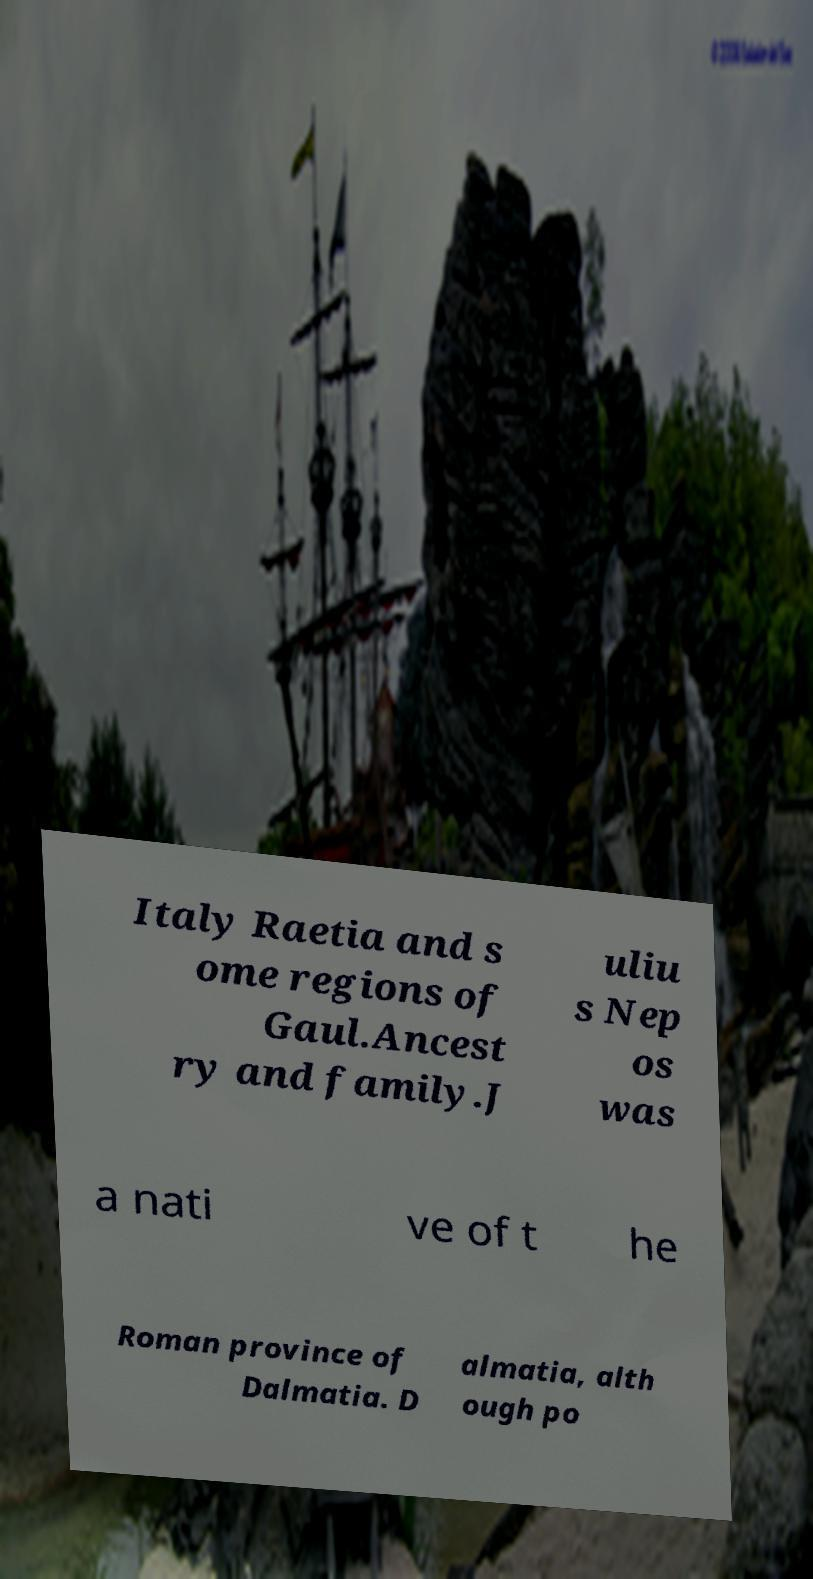There's text embedded in this image that I need extracted. Can you transcribe it verbatim? Italy Raetia and s ome regions of Gaul.Ancest ry and family.J uliu s Nep os was a nati ve of t he Roman province of Dalmatia. D almatia, alth ough po 